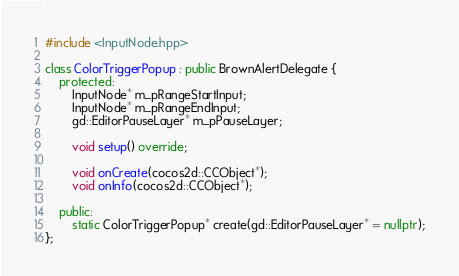<code> <loc_0><loc_0><loc_500><loc_500><_C++_>#include <InputNode.hpp>

class ColorTriggerPopup : public BrownAlertDelegate {
    protected:
        InputNode* m_pRangeStartInput;
        InputNode* m_pRangeEndInput;
        gd::EditorPauseLayer* m_pPauseLayer;

        void setup() override;

        void onCreate(cocos2d::CCObject*);
        void onInfo(cocos2d::CCObject*);

    public:
        static ColorTriggerPopup* create(gd::EditorPauseLayer* = nullptr);
};
</code> 